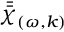<formula> <loc_0><loc_0><loc_500><loc_500>\bar { \bar { \chi } } _ { ( \omega , k ) }</formula> 